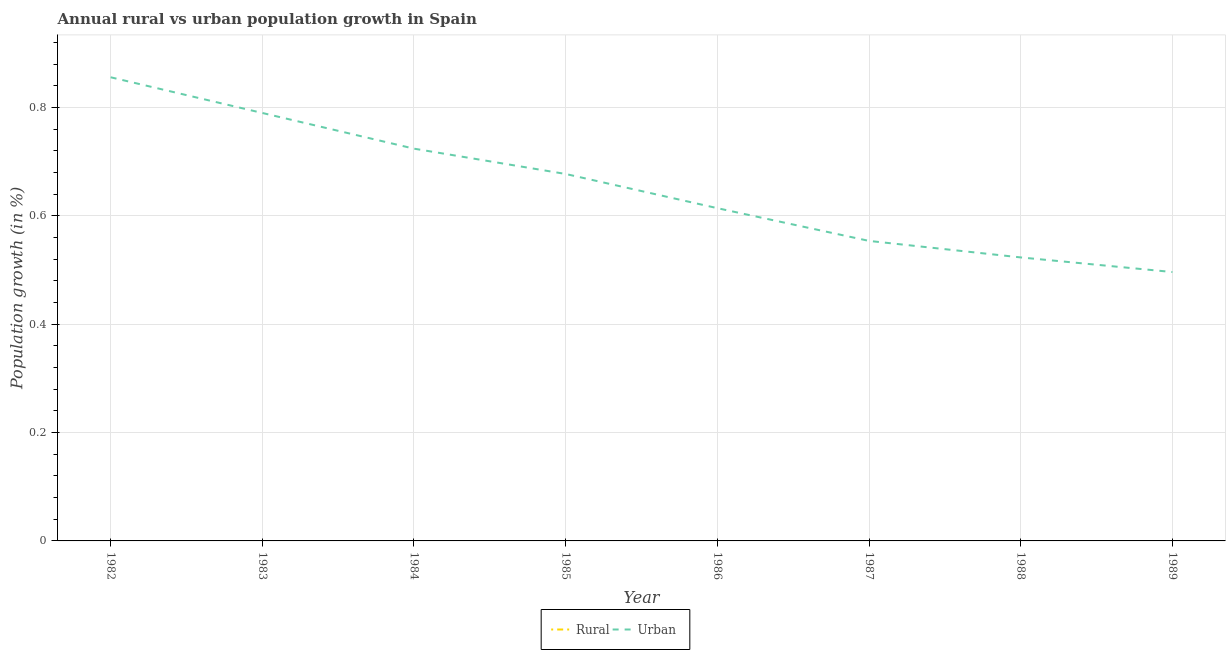Does the line corresponding to rural population growth intersect with the line corresponding to urban population growth?
Your answer should be very brief. No. Is the number of lines equal to the number of legend labels?
Ensure brevity in your answer.  No. Across all years, what is the maximum urban population growth?
Provide a succinct answer. 0.86. Across all years, what is the minimum urban population growth?
Your answer should be compact. 0.5. In which year was the urban population growth maximum?
Offer a terse response. 1982. What is the total rural population growth in the graph?
Provide a short and direct response. 0. What is the difference between the urban population growth in 1982 and that in 1986?
Give a very brief answer. 0.24. What is the difference between the urban population growth in 1982 and the rural population growth in 1983?
Ensure brevity in your answer.  0.86. In how many years, is the urban population growth greater than 0.68 %?
Your answer should be very brief. 3. What is the ratio of the urban population growth in 1984 to that in 1985?
Your answer should be compact. 1.07. What is the difference between the highest and the second highest urban population growth?
Provide a succinct answer. 0.07. What is the difference between the highest and the lowest urban population growth?
Ensure brevity in your answer.  0.36. Is the rural population growth strictly less than the urban population growth over the years?
Ensure brevity in your answer.  Yes. How many years are there in the graph?
Keep it short and to the point. 8. What is the difference between two consecutive major ticks on the Y-axis?
Your answer should be compact. 0.2. Does the graph contain grids?
Your answer should be compact. Yes. Where does the legend appear in the graph?
Provide a succinct answer. Bottom center. How many legend labels are there?
Your response must be concise. 2. How are the legend labels stacked?
Make the answer very short. Horizontal. What is the title of the graph?
Your response must be concise. Annual rural vs urban population growth in Spain. What is the label or title of the X-axis?
Your answer should be compact. Year. What is the label or title of the Y-axis?
Your response must be concise. Population growth (in %). What is the Population growth (in %) of Rural in 1982?
Make the answer very short. 0. What is the Population growth (in %) in Urban  in 1982?
Your answer should be very brief. 0.86. What is the Population growth (in %) of Rural in 1983?
Your answer should be compact. 0. What is the Population growth (in %) of Urban  in 1983?
Offer a very short reply. 0.79. What is the Population growth (in %) in Urban  in 1984?
Make the answer very short. 0.72. What is the Population growth (in %) of Urban  in 1985?
Your answer should be very brief. 0.68. What is the Population growth (in %) in Rural in 1986?
Ensure brevity in your answer.  0. What is the Population growth (in %) in Urban  in 1986?
Make the answer very short. 0.61. What is the Population growth (in %) of Urban  in 1987?
Provide a succinct answer. 0.55. What is the Population growth (in %) of Rural in 1988?
Provide a short and direct response. 0. What is the Population growth (in %) of Urban  in 1988?
Your response must be concise. 0.52. What is the Population growth (in %) in Rural in 1989?
Offer a terse response. 0. What is the Population growth (in %) of Urban  in 1989?
Offer a very short reply. 0.5. Across all years, what is the maximum Population growth (in %) of Urban ?
Give a very brief answer. 0.86. Across all years, what is the minimum Population growth (in %) in Urban ?
Make the answer very short. 0.5. What is the total Population growth (in %) in Rural in the graph?
Ensure brevity in your answer.  0. What is the total Population growth (in %) in Urban  in the graph?
Keep it short and to the point. 5.24. What is the difference between the Population growth (in %) in Urban  in 1982 and that in 1983?
Your answer should be compact. 0.07. What is the difference between the Population growth (in %) of Urban  in 1982 and that in 1984?
Keep it short and to the point. 0.13. What is the difference between the Population growth (in %) in Urban  in 1982 and that in 1985?
Offer a terse response. 0.18. What is the difference between the Population growth (in %) in Urban  in 1982 and that in 1986?
Offer a very short reply. 0.24. What is the difference between the Population growth (in %) in Urban  in 1982 and that in 1987?
Your response must be concise. 0.3. What is the difference between the Population growth (in %) of Urban  in 1982 and that in 1988?
Give a very brief answer. 0.33. What is the difference between the Population growth (in %) of Urban  in 1982 and that in 1989?
Give a very brief answer. 0.36. What is the difference between the Population growth (in %) of Urban  in 1983 and that in 1984?
Ensure brevity in your answer.  0.07. What is the difference between the Population growth (in %) of Urban  in 1983 and that in 1985?
Offer a very short reply. 0.11. What is the difference between the Population growth (in %) of Urban  in 1983 and that in 1986?
Ensure brevity in your answer.  0.18. What is the difference between the Population growth (in %) of Urban  in 1983 and that in 1987?
Make the answer very short. 0.24. What is the difference between the Population growth (in %) in Urban  in 1983 and that in 1988?
Give a very brief answer. 0.27. What is the difference between the Population growth (in %) in Urban  in 1983 and that in 1989?
Make the answer very short. 0.29. What is the difference between the Population growth (in %) in Urban  in 1984 and that in 1985?
Make the answer very short. 0.05. What is the difference between the Population growth (in %) in Urban  in 1984 and that in 1986?
Offer a very short reply. 0.11. What is the difference between the Population growth (in %) of Urban  in 1984 and that in 1987?
Your response must be concise. 0.17. What is the difference between the Population growth (in %) in Urban  in 1984 and that in 1988?
Ensure brevity in your answer.  0.2. What is the difference between the Population growth (in %) of Urban  in 1984 and that in 1989?
Offer a terse response. 0.23. What is the difference between the Population growth (in %) of Urban  in 1985 and that in 1986?
Your answer should be compact. 0.06. What is the difference between the Population growth (in %) in Urban  in 1985 and that in 1987?
Keep it short and to the point. 0.12. What is the difference between the Population growth (in %) in Urban  in 1985 and that in 1988?
Make the answer very short. 0.15. What is the difference between the Population growth (in %) of Urban  in 1985 and that in 1989?
Your answer should be very brief. 0.18. What is the difference between the Population growth (in %) in Urban  in 1986 and that in 1987?
Offer a terse response. 0.06. What is the difference between the Population growth (in %) in Urban  in 1986 and that in 1988?
Your answer should be compact. 0.09. What is the difference between the Population growth (in %) of Urban  in 1986 and that in 1989?
Keep it short and to the point. 0.12. What is the difference between the Population growth (in %) of Urban  in 1987 and that in 1988?
Provide a succinct answer. 0.03. What is the difference between the Population growth (in %) of Urban  in 1987 and that in 1989?
Give a very brief answer. 0.06. What is the difference between the Population growth (in %) in Urban  in 1988 and that in 1989?
Provide a short and direct response. 0.03. What is the average Population growth (in %) in Rural per year?
Your answer should be compact. 0. What is the average Population growth (in %) in Urban  per year?
Offer a terse response. 0.65. What is the ratio of the Population growth (in %) of Urban  in 1982 to that in 1983?
Provide a short and direct response. 1.08. What is the ratio of the Population growth (in %) of Urban  in 1982 to that in 1984?
Provide a short and direct response. 1.18. What is the ratio of the Population growth (in %) in Urban  in 1982 to that in 1985?
Offer a very short reply. 1.26. What is the ratio of the Population growth (in %) in Urban  in 1982 to that in 1986?
Your answer should be very brief. 1.39. What is the ratio of the Population growth (in %) in Urban  in 1982 to that in 1987?
Ensure brevity in your answer.  1.55. What is the ratio of the Population growth (in %) in Urban  in 1982 to that in 1988?
Offer a very short reply. 1.64. What is the ratio of the Population growth (in %) of Urban  in 1982 to that in 1989?
Provide a short and direct response. 1.72. What is the ratio of the Population growth (in %) in Urban  in 1983 to that in 1984?
Your answer should be compact. 1.09. What is the ratio of the Population growth (in %) in Urban  in 1983 to that in 1985?
Keep it short and to the point. 1.17. What is the ratio of the Population growth (in %) of Urban  in 1983 to that in 1986?
Provide a succinct answer. 1.29. What is the ratio of the Population growth (in %) in Urban  in 1983 to that in 1987?
Keep it short and to the point. 1.43. What is the ratio of the Population growth (in %) of Urban  in 1983 to that in 1988?
Offer a terse response. 1.51. What is the ratio of the Population growth (in %) in Urban  in 1983 to that in 1989?
Your answer should be very brief. 1.59. What is the ratio of the Population growth (in %) in Urban  in 1984 to that in 1985?
Ensure brevity in your answer.  1.07. What is the ratio of the Population growth (in %) in Urban  in 1984 to that in 1986?
Your response must be concise. 1.18. What is the ratio of the Population growth (in %) in Urban  in 1984 to that in 1987?
Provide a succinct answer. 1.31. What is the ratio of the Population growth (in %) in Urban  in 1984 to that in 1988?
Offer a terse response. 1.38. What is the ratio of the Population growth (in %) of Urban  in 1984 to that in 1989?
Provide a succinct answer. 1.46. What is the ratio of the Population growth (in %) of Urban  in 1985 to that in 1986?
Ensure brevity in your answer.  1.1. What is the ratio of the Population growth (in %) of Urban  in 1985 to that in 1987?
Provide a succinct answer. 1.22. What is the ratio of the Population growth (in %) in Urban  in 1985 to that in 1988?
Provide a short and direct response. 1.29. What is the ratio of the Population growth (in %) of Urban  in 1985 to that in 1989?
Provide a succinct answer. 1.36. What is the ratio of the Population growth (in %) in Urban  in 1986 to that in 1987?
Offer a very short reply. 1.11. What is the ratio of the Population growth (in %) in Urban  in 1986 to that in 1988?
Keep it short and to the point. 1.17. What is the ratio of the Population growth (in %) in Urban  in 1986 to that in 1989?
Give a very brief answer. 1.24. What is the ratio of the Population growth (in %) of Urban  in 1987 to that in 1988?
Your answer should be very brief. 1.06. What is the ratio of the Population growth (in %) of Urban  in 1987 to that in 1989?
Offer a very short reply. 1.12. What is the ratio of the Population growth (in %) of Urban  in 1988 to that in 1989?
Provide a succinct answer. 1.05. What is the difference between the highest and the second highest Population growth (in %) in Urban ?
Ensure brevity in your answer.  0.07. What is the difference between the highest and the lowest Population growth (in %) of Urban ?
Offer a terse response. 0.36. 